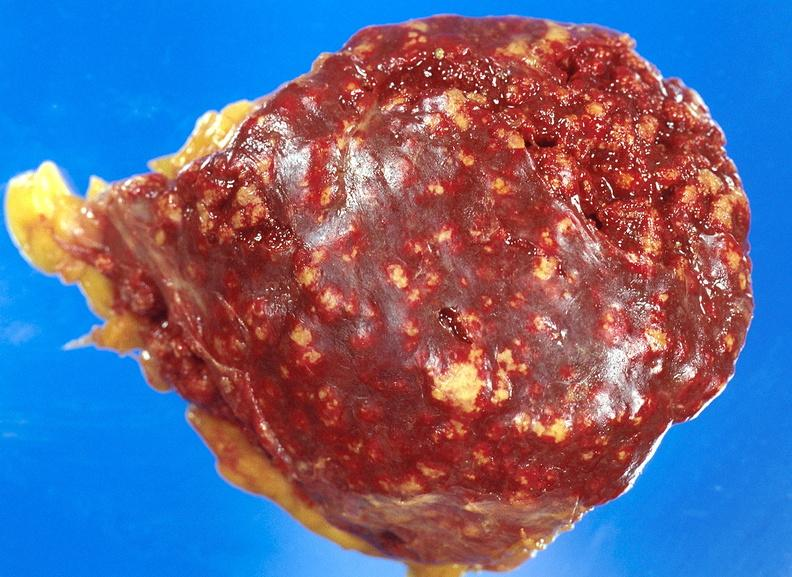what is present?
Answer the question using a single word or phrase. Hematologic 